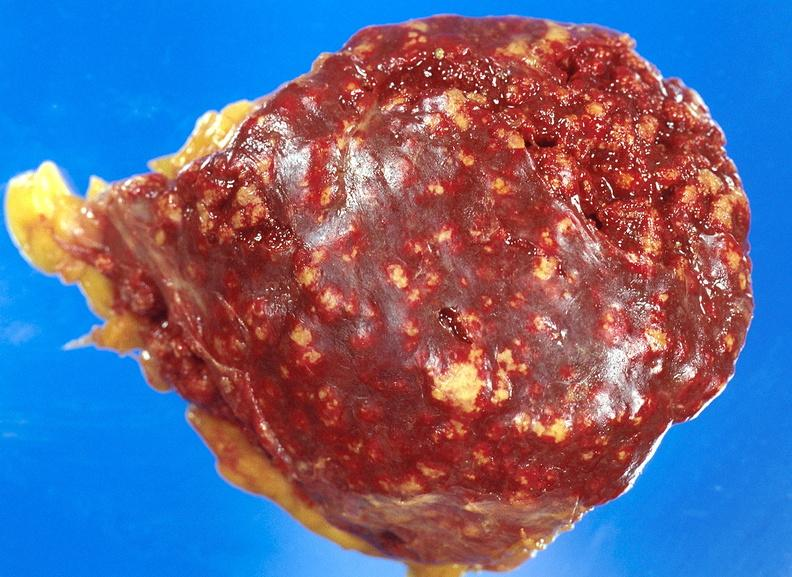what is present?
Answer the question using a single word or phrase. Hematologic 